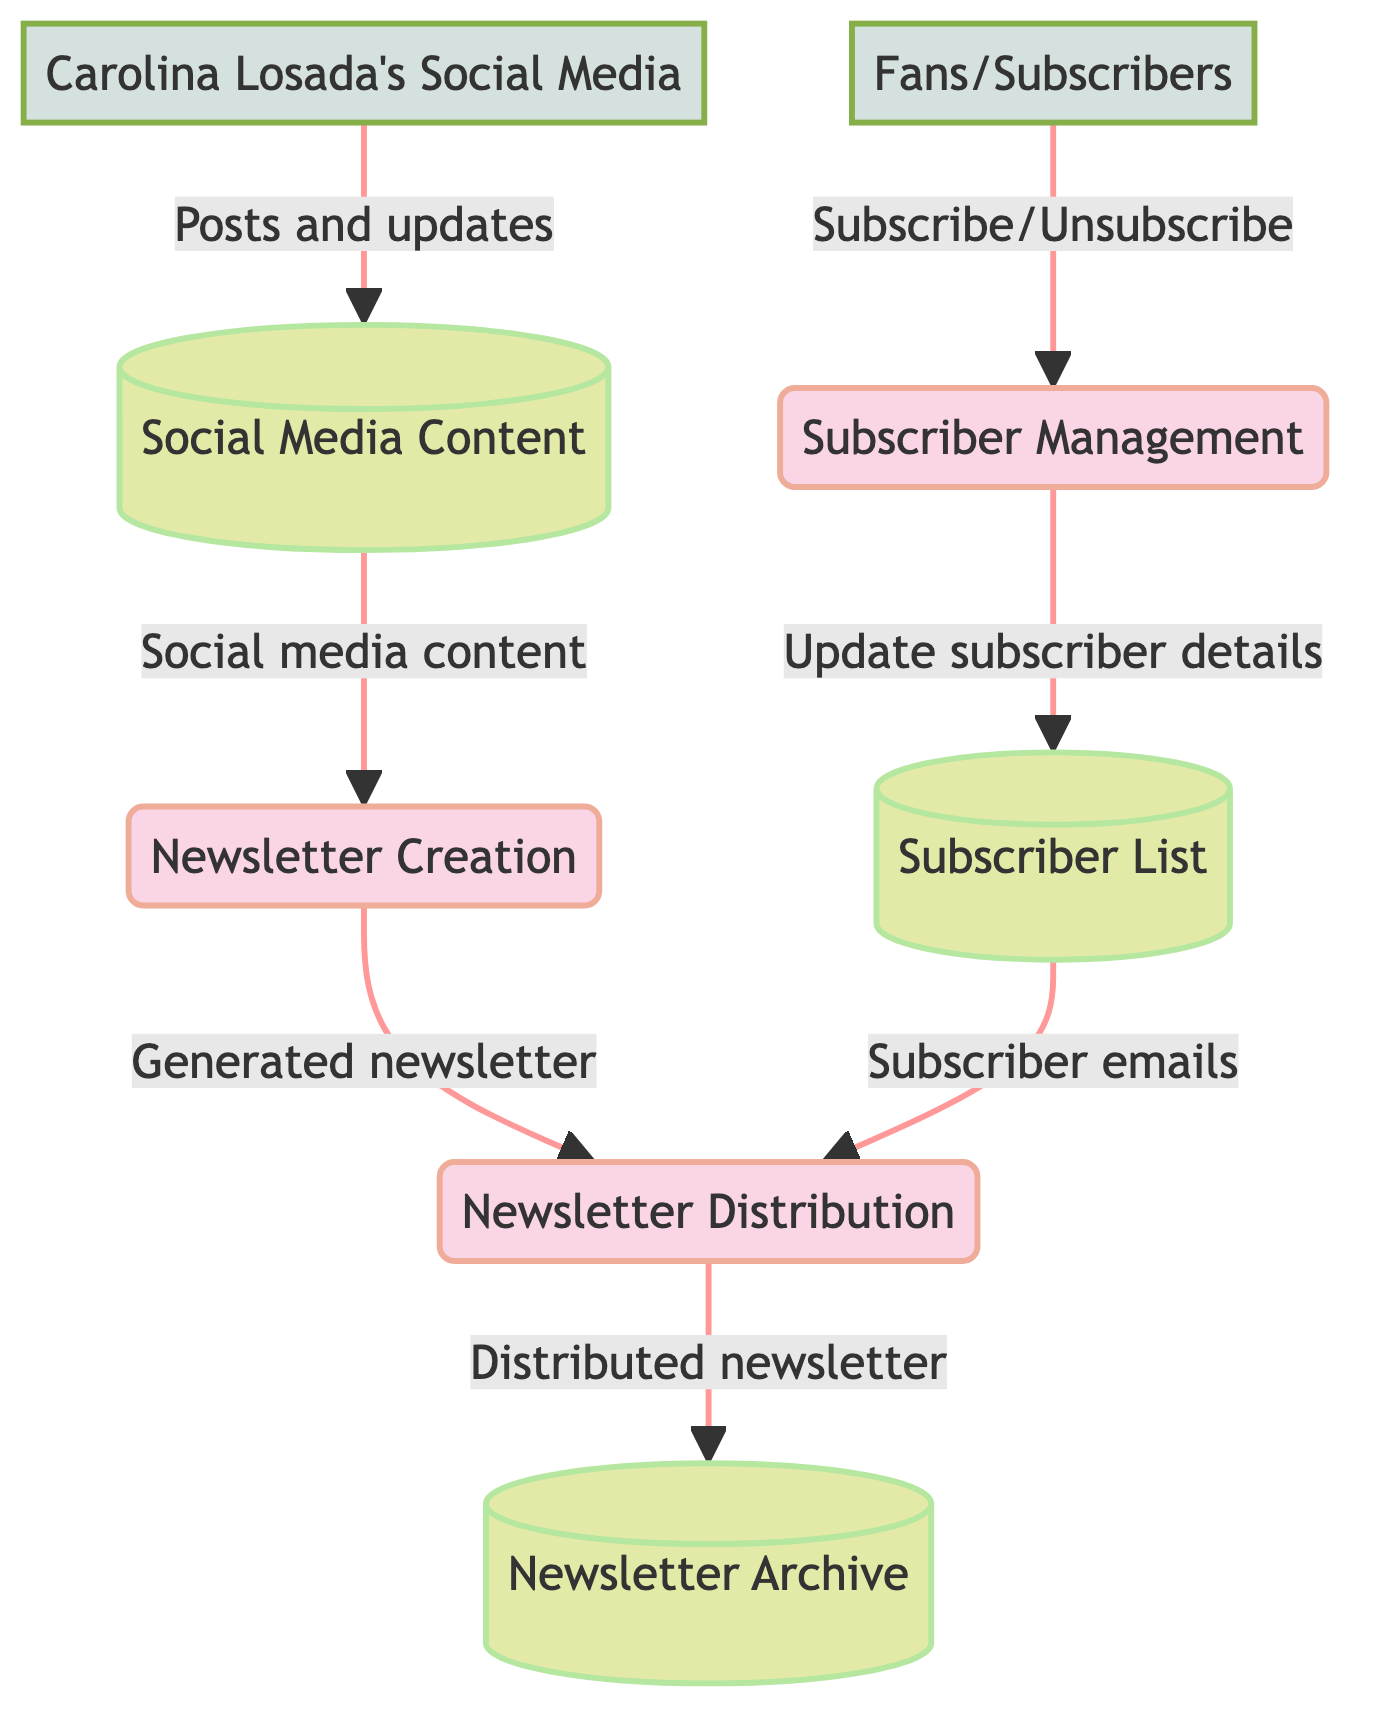What are the three processes in the diagram? The diagram lists three processes: Newsletter Creation, Subscriber Management, and Newsletter Distribution.
Answer: Newsletter Creation, Subscriber Management, Newsletter Distribution How many data stores are present in the diagram? There are three data stores present in the diagram: Social Media Content, Subscriber List, and Newsletter Archive.
Answer: 3 What flows from Social Media Content to Newsletter Creation? The flow from Social Media Content to Newsletter Creation is described as "Social media content." This represents the transfer of posts and updates needed to create the newsletter.
Answer: Social media content Who provides posts and updates to Social Media Content? Carolina Losada's Social Media is identified as the external entity that sources the posts and updates used for the Social Media Content datastore.
Answer: Carolina Losada's Social Media Which process updates the Subscriber List? The Subscriber Management process is responsible for updating the Subscriber List by adding or removing subscribers based on their actions.
Answer: Subscriber Management What happens to the distributed newsletter in the diagram? After the newsletter is distributed, it is stored in the Newsletter Archive for future reference and historical access.
Answer: Stored in the Newsletter Archive What type of information does the Subscriber List contain? The Subscriber List contains the email addresses and names of all subscribers who have signed up for the newsletter, serving as the contact database for distribution.
Answer: Email addresses and names What is the flow between the Newsletter Creation and Newsletter Distribution processes? The flow between these two processes is described as "Generated newsletter," indicating that the content created in the Newsletter Creation process is sent to Newsletter Distribution for delivery.
Answer: Generated newsletter How do fans interact with the Subscriber Management process? Fans interact with the Subscriber Management process by subscribing or unsubscribing to the newsletter, which allows them to manage their status on the mailing list.
Answer: Subscribe/Unsubscribe 